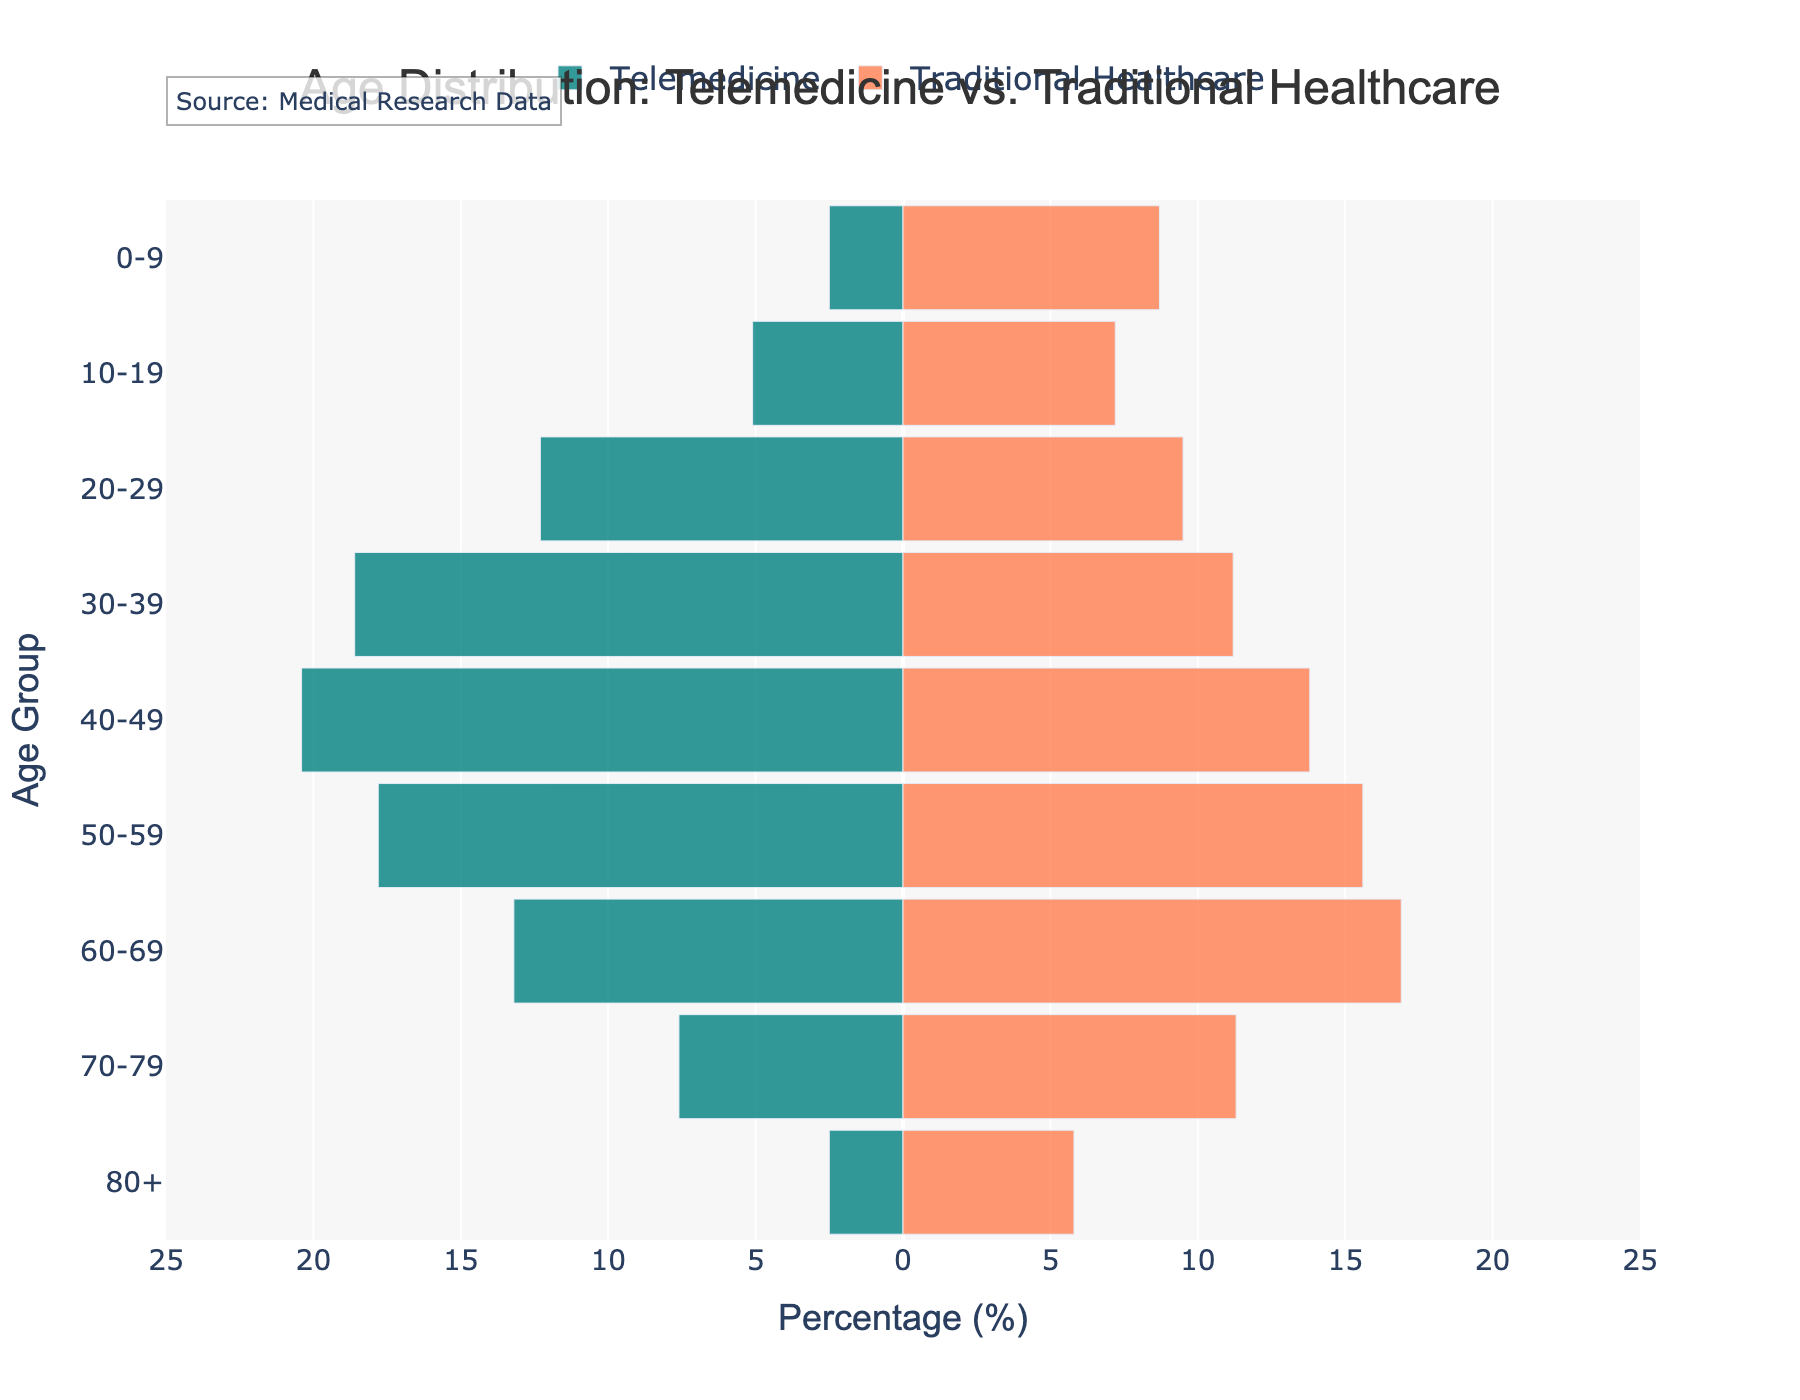What is the title of the figure? The title of the figure is located at the top and states "Age Distribution: Telemedicine vs. Traditional Healthcare".
Answer: Age Distribution: Telemedicine vs. Traditional Healthcare Which age group has the highest percentage using telemedicine? By looking at the length of the bars in the "Telemedicine" section (colored in teal), the 40-49 age group has the highest percentage.
Answer: 40-49 How many age groups are represented in the figure? By counting the labels on the y-axis that represent different age groups, there are 9 age groups in total.
Answer: 9 What is the percentage difference between telemedicine and traditional healthcare for the 30-39 age group? The telemedicine percentage for the 30-39 age group is 18.6%, and for traditional healthcare, it is 11.2%. The difference is 18.6 - 11.2 = 7.4%.
Answer: 7.4% Which age group has the smallest percentage in traditional healthcare? By examining the shortness of the bars in the "Traditional Healthcare" section (colored in coral), the 0-9 age group has the smallest percentage.
Answer: 0-9 Compare the age groups 50-59 in terms of using telemedicine versus traditional healthcare. The percentage for the age group 50-59 is 17.8% in telemedicine and 15.6% in traditional healthcare. Telemedicine usage is slightly higher.
Answer: Telemedicine is higher Is telemedicine more popular among younger or older age groups? Generally observing the bars, younger age groups (20-49) have higher percentages for telemedicine compared to the older age groups (50 and above).
Answer: Younger age groups Calculate the average percentage of traditional healthcare usage for patients aged 60 and above. For traditional healthcare, the percentages for age groups 60-69, 70-79, and 80+ are 16.9%, 11.3%, and 5.8%, respectively. The average is (16.9 + 11.3 + 5.8) / 3 = 11.33%.
Answer: 11.33% Which age group shows a reverse trend, where traditional healthcare usage is higher than telemedicine? Observing the bars, the age group 60-69 shows higher traditional healthcare usage (16.9%) compared to telemedicine (13.2%).
Answer: 60-69 By how much does the 40-49 age group outnumber the 80+ age group in telemedicine usage? The percentage for the 40-49 age group in telemedicine is 20.4%, while for the 80+ age group, it is 2.5%. The difference is 20.4 - 2.5 = 17.9%.
Answer: 17.9% 